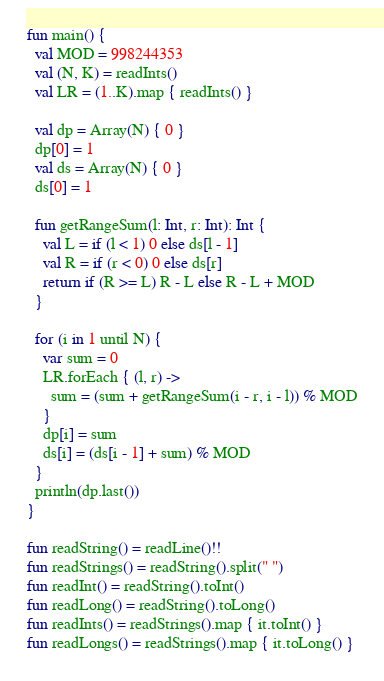<code> <loc_0><loc_0><loc_500><loc_500><_Kotlin_>fun main() {
  val MOD = 998244353
  val (N, K) = readInts()
  val LR = (1..K).map { readInts() }

  val dp = Array(N) { 0 }
  dp[0] = 1
  val ds = Array(N) { 0 }
  ds[0] = 1

  fun getRangeSum(l: Int, r: Int): Int {
    val L = if (l < 1) 0 else ds[l - 1]
    val R = if (r < 0) 0 else ds[r]
    return if (R >= L) R - L else R - L + MOD
  }

  for (i in 1 until N) {
    var sum = 0
    LR.forEach { (l, r) ->
      sum = (sum + getRangeSum(i - r, i - l)) % MOD
    }
    dp[i] = sum
    ds[i] = (ds[i - 1] + sum) % MOD
  }
  println(dp.last())
}

fun readString() = readLine()!!
fun readStrings() = readString().split(" ")
fun readInt() = readString().toInt()
fun readLong() = readString().toLong()
fun readInts() = readStrings().map { it.toInt() }
fun readLongs() = readStrings().map { it.toLong() }
</code> 